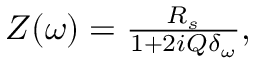<formula> <loc_0><loc_0><loc_500><loc_500>\begin{array} { r } { Z ( \omega ) = \frac { R _ { s } } { 1 + 2 i Q \delta _ { \omega } } , } \end{array}</formula> 